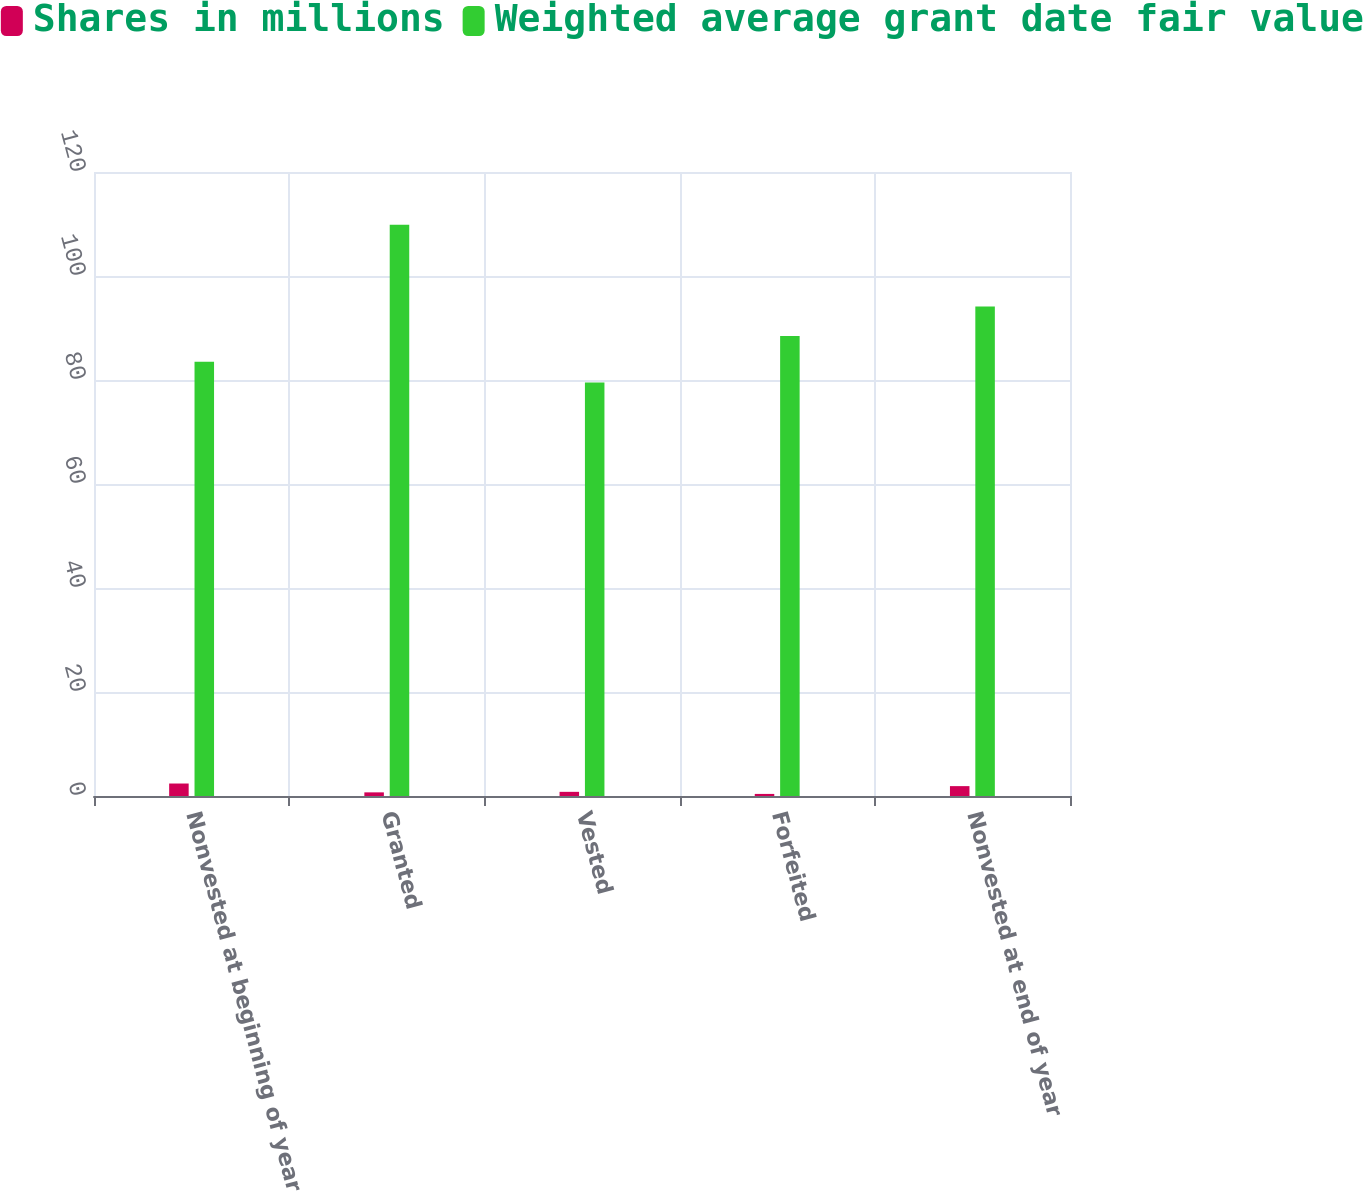Convert chart to OTSL. <chart><loc_0><loc_0><loc_500><loc_500><stacked_bar_chart><ecel><fcel>Nonvested at beginning of year<fcel>Granted<fcel>Vested<fcel>Forfeited<fcel>Nonvested at end of year<nl><fcel>Shares in millions<fcel>2.4<fcel>0.7<fcel>0.8<fcel>0.4<fcel>1.9<nl><fcel>Weighted average grant date fair value<fcel>83.5<fcel>109.86<fcel>79.54<fcel>88.45<fcel>94.13<nl></chart> 